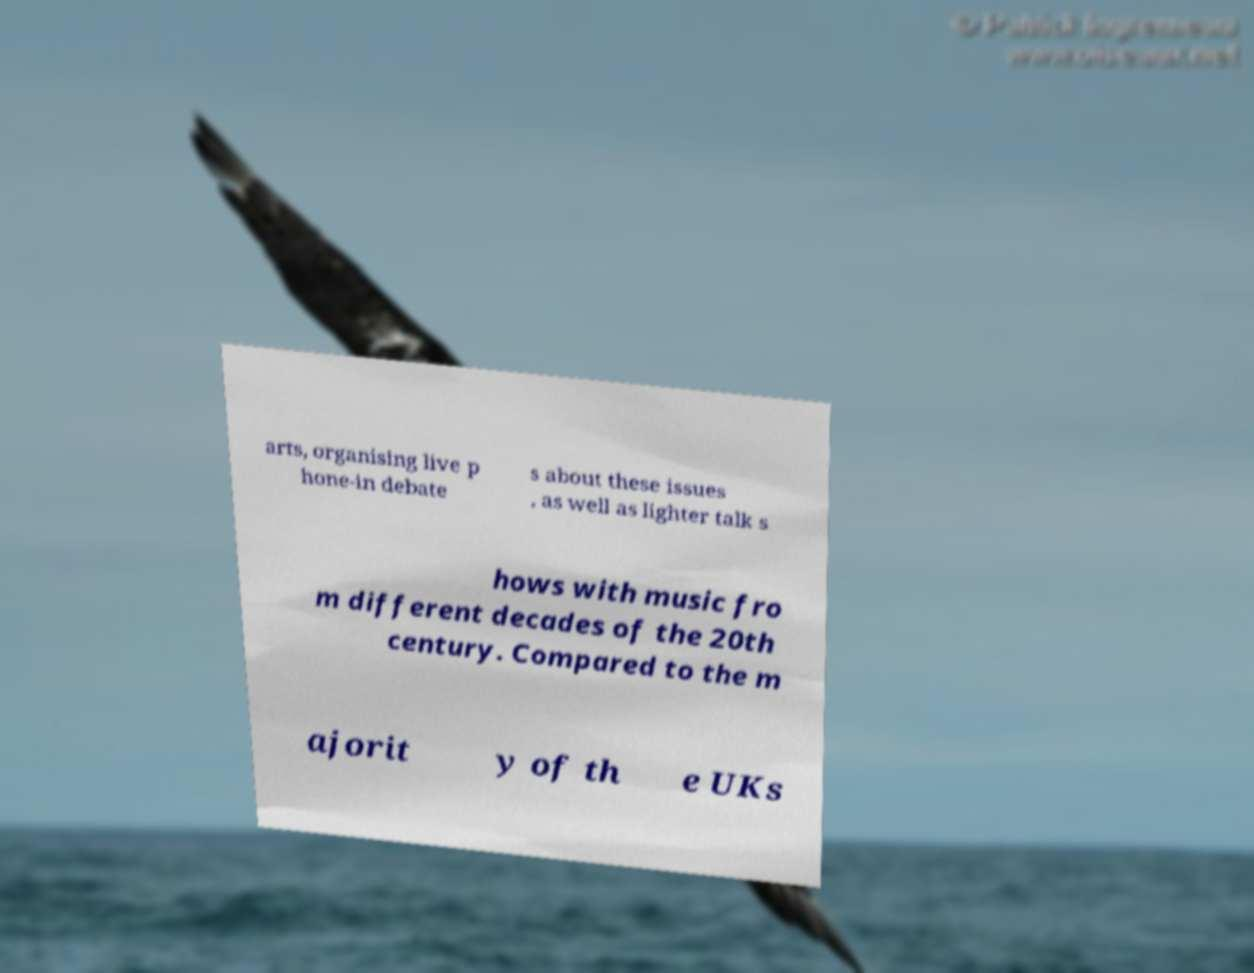Could you extract and type out the text from this image? arts, organising live p hone-in debate s about these issues , as well as lighter talk s hows with music fro m different decades of the 20th century. Compared to the m ajorit y of th e UKs 